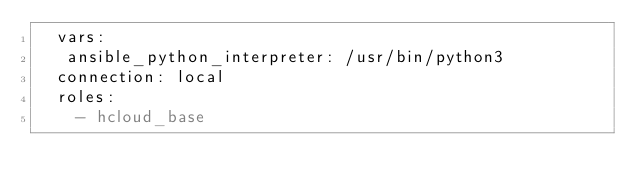Convert code to text. <code><loc_0><loc_0><loc_500><loc_500><_YAML_>  vars:
   ansible_python_interpreter: /usr/bin/python3
  connection: local
  roles:
    - hcloud_base
</code> 